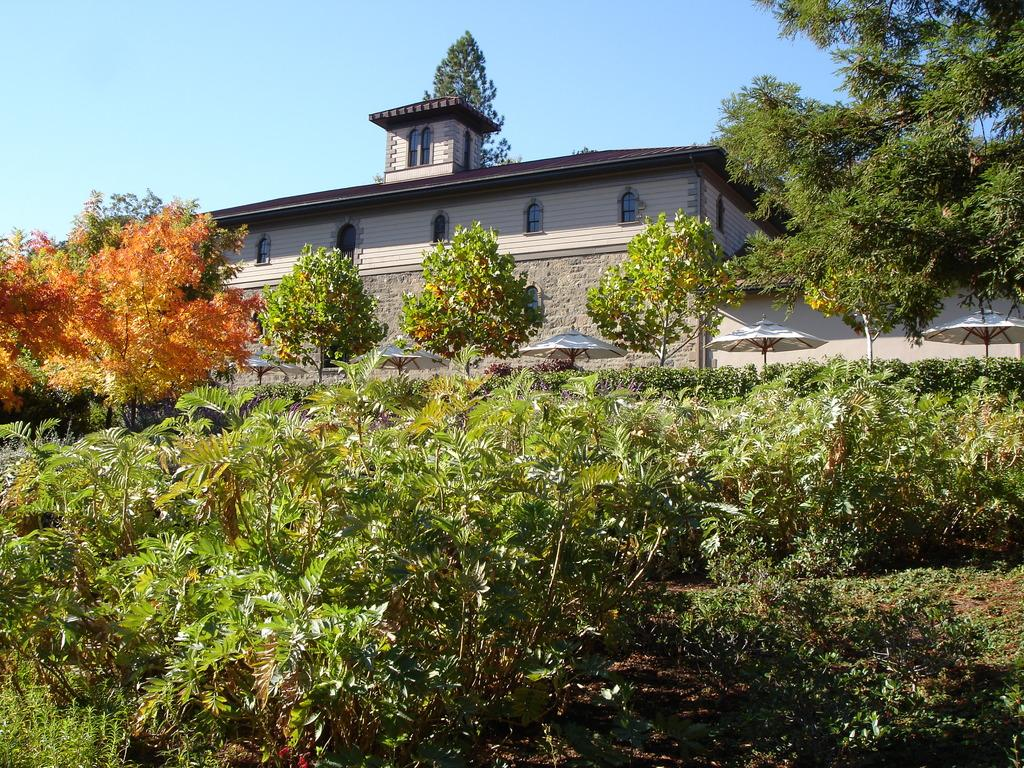What is the main structure in the center of the image? There is a building in the center of the image. What type of natural elements can be seen in the image? There are trees and plants in the image. What objects are present for protection from the elements? There are umbrellas in the image. What is visible at the top of the image? The sky is visible at the top of the image. What is the value of the grandmother's house in the image? There is no mention of a grandmother or a house in the image, so it is not possible to determine the value of a house. 